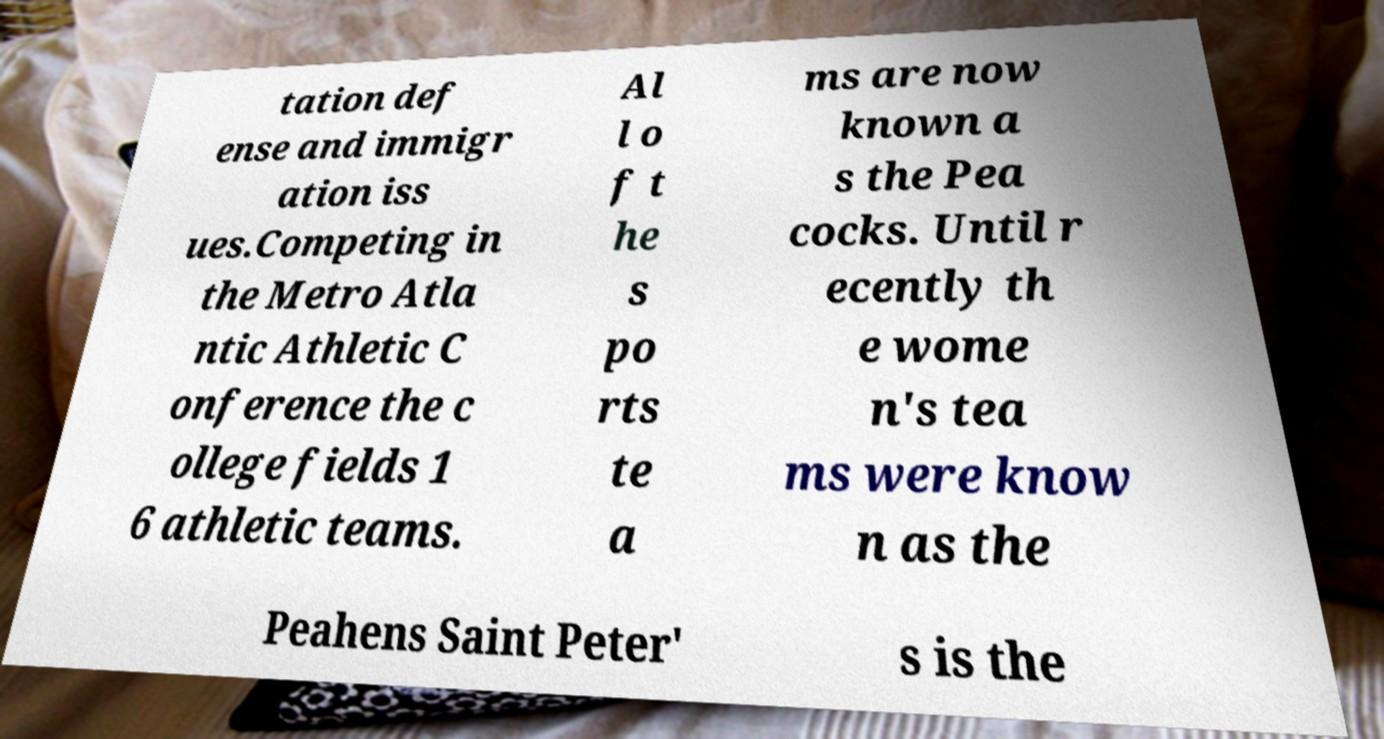Could you assist in decoding the text presented in this image and type it out clearly? tation def ense and immigr ation iss ues.Competing in the Metro Atla ntic Athletic C onference the c ollege fields 1 6 athletic teams. Al l o f t he s po rts te a ms are now known a s the Pea cocks. Until r ecently th e wome n's tea ms were know n as the Peahens Saint Peter' s is the 